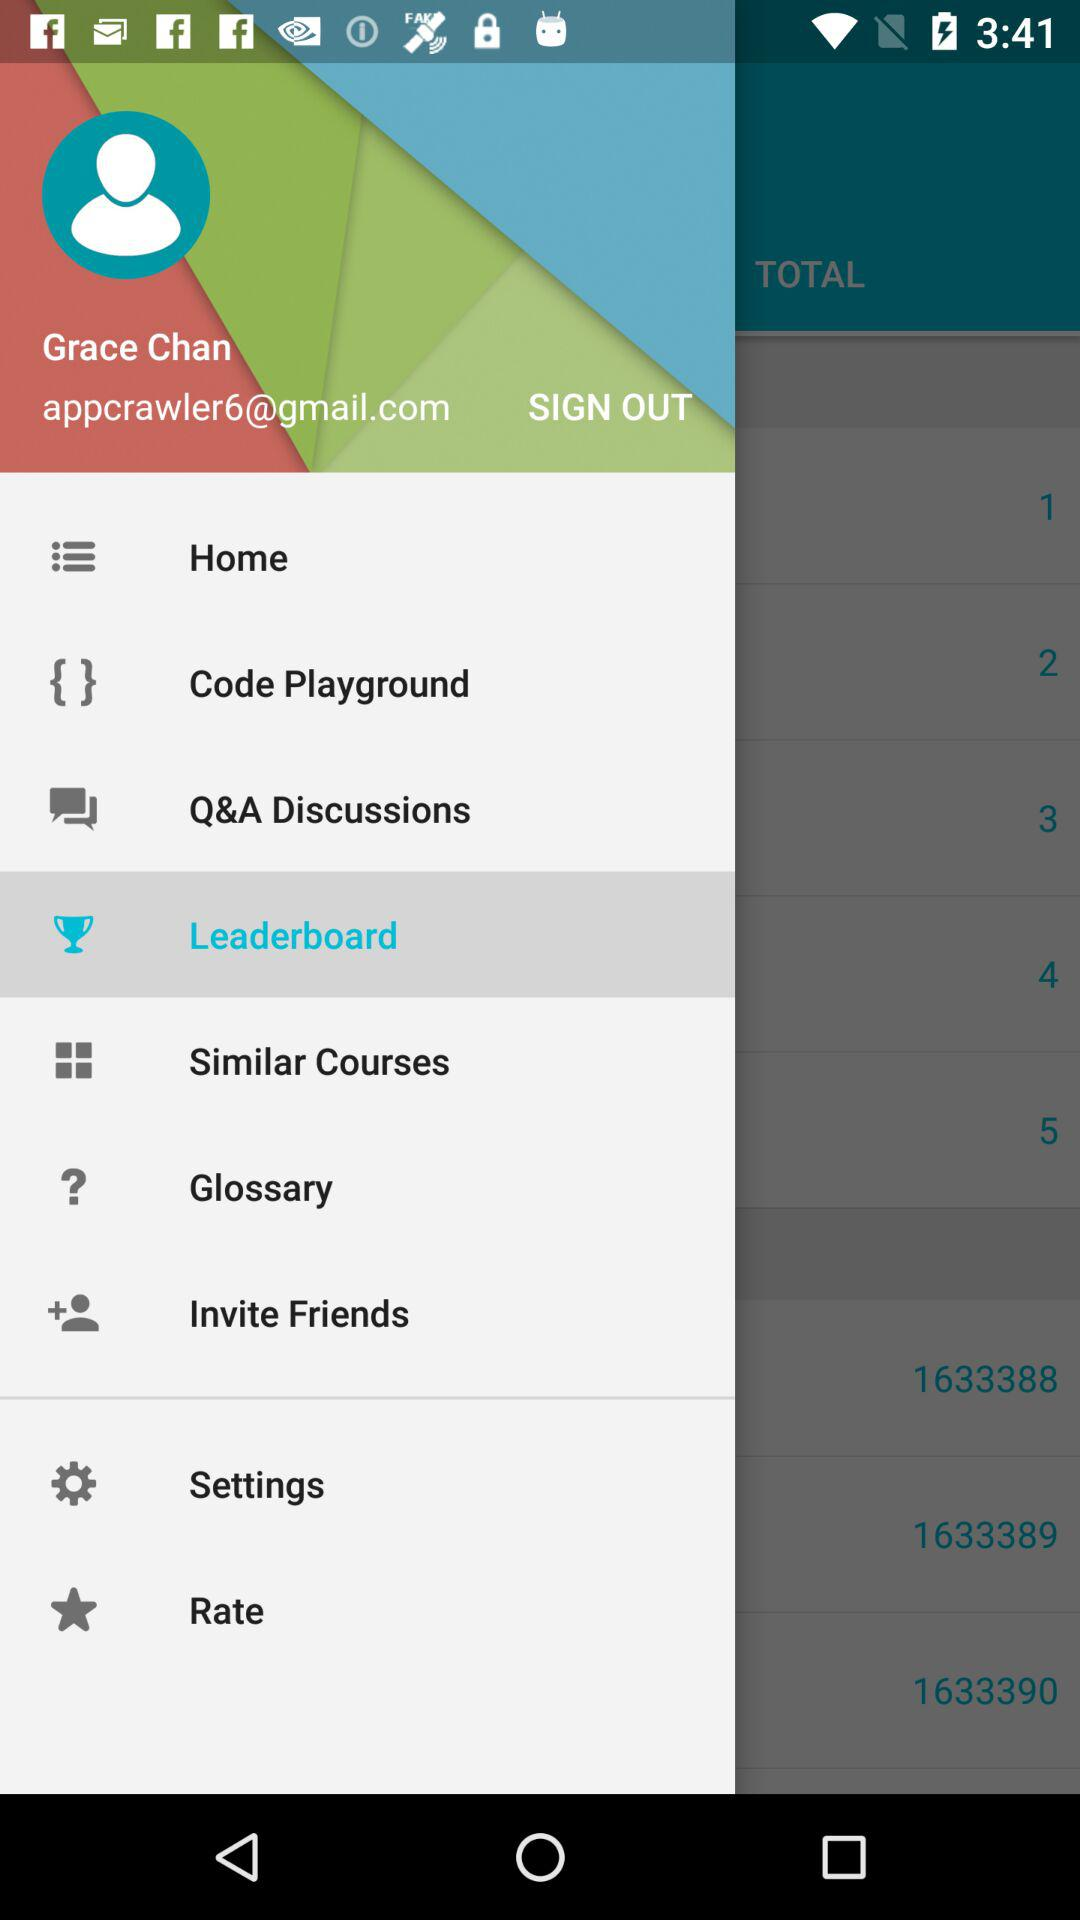Which is the selected item in the menu? The selected item is "Leaderboard". 